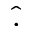Convert formula to latex. <formula><loc_0><loc_0><loc_500><loc_500>\hat { . }</formula> 